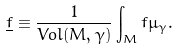Convert formula to latex. <formula><loc_0><loc_0><loc_500><loc_500>\underline { f } \equiv \frac { 1 } { V o l ( M , \gamma ) } \int _ { M } f \mu _ { \gamma } .</formula> 